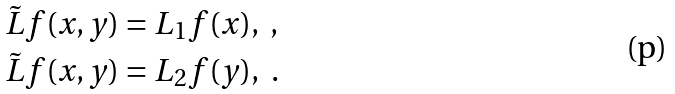<formula> <loc_0><loc_0><loc_500><loc_500>\tilde { L } f ( x , y ) & = L _ { 1 } f ( x ) , \ , \\ \tilde { L } f ( x , y ) & = L _ { 2 } f ( y ) , \ .</formula> 